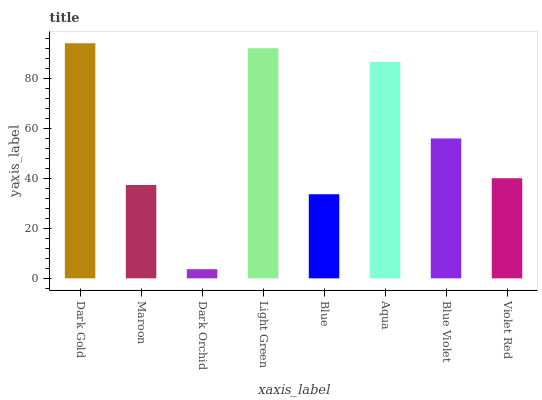Is Dark Orchid the minimum?
Answer yes or no. Yes. Is Dark Gold the maximum?
Answer yes or no. Yes. Is Maroon the minimum?
Answer yes or no. No. Is Maroon the maximum?
Answer yes or no. No. Is Dark Gold greater than Maroon?
Answer yes or no. Yes. Is Maroon less than Dark Gold?
Answer yes or no. Yes. Is Maroon greater than Dark Gold?
Answer yes or no. No. Is Dark Gold less than Maroon?
Answer yes or no. No. Is Blue Violet the high median?
Answer yes or no. Yes. Is Violet Red the low median?
Answer yes or no. Yes. Is Light Green the high median?
Answer yes or no. No. Is Dark Orchid the low median?
Answer yes or no. No. 